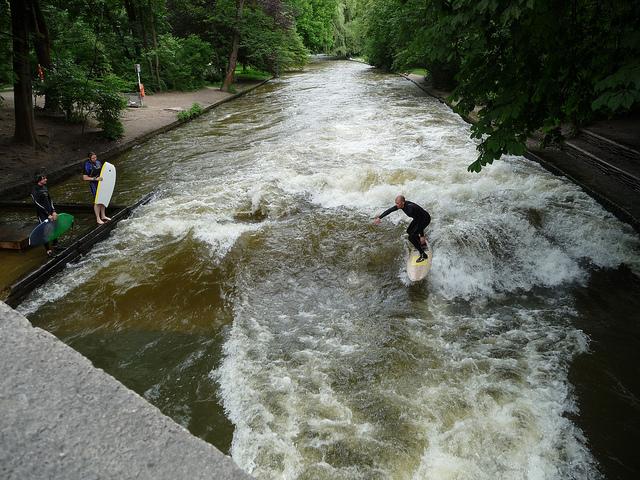What is the person doing in the water?
Quick response, please. Surfing. Is this picture taken in the ocean?
Quick response, please. No. Where is the camera man standing?
Keep it brief. On bridge. 